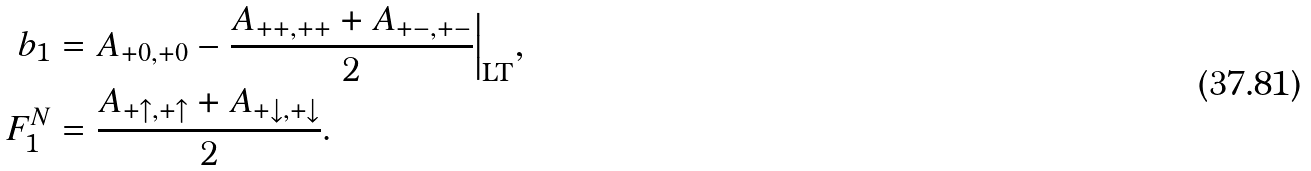<formula> <loc_0><loc_0><loc_500><loc_500>b _ { 1 } & = A _ { + 0 , + 0 } - \frac { A _ { + + , + + } + A _ { + - , + - } } { 2 } \Big | _ { \text {LT} } , \\ F _ { 1 } ^ { N } & = \frac { A _ { + \uparrow , + \uparrow } + A _ { + \downarrow , + \downarrow } } { 2 } .</formula> 